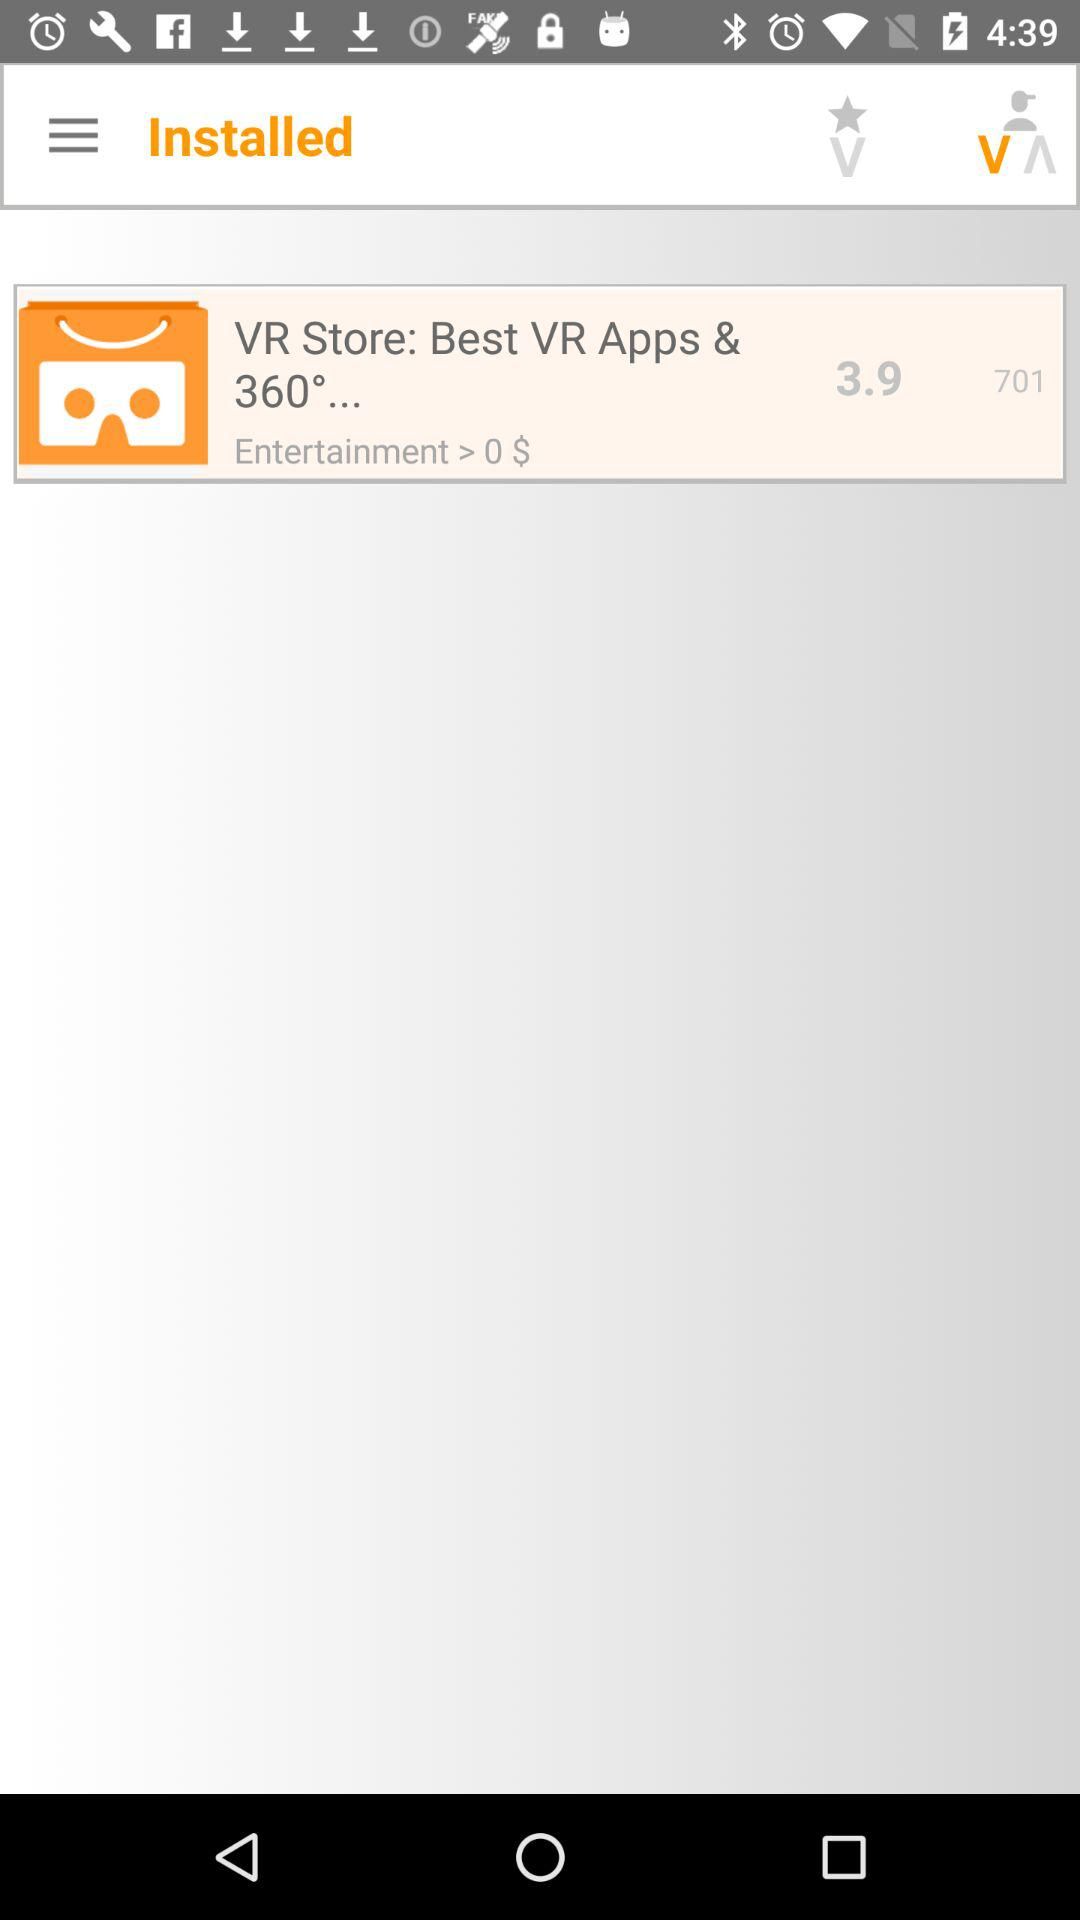What is the application name? The application name is "VR Store". 